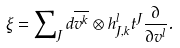Convert formula to latex. <formula><loc_0><loc_0><loc_500><loc_500>\xi = \sum \nolimits _ { J } d \overline { v ^ { k } } \otimes h _ { J , k } ^ { l } t ^ { J } \frac { \partial } { \partial v ^ { l } } .</formula> 